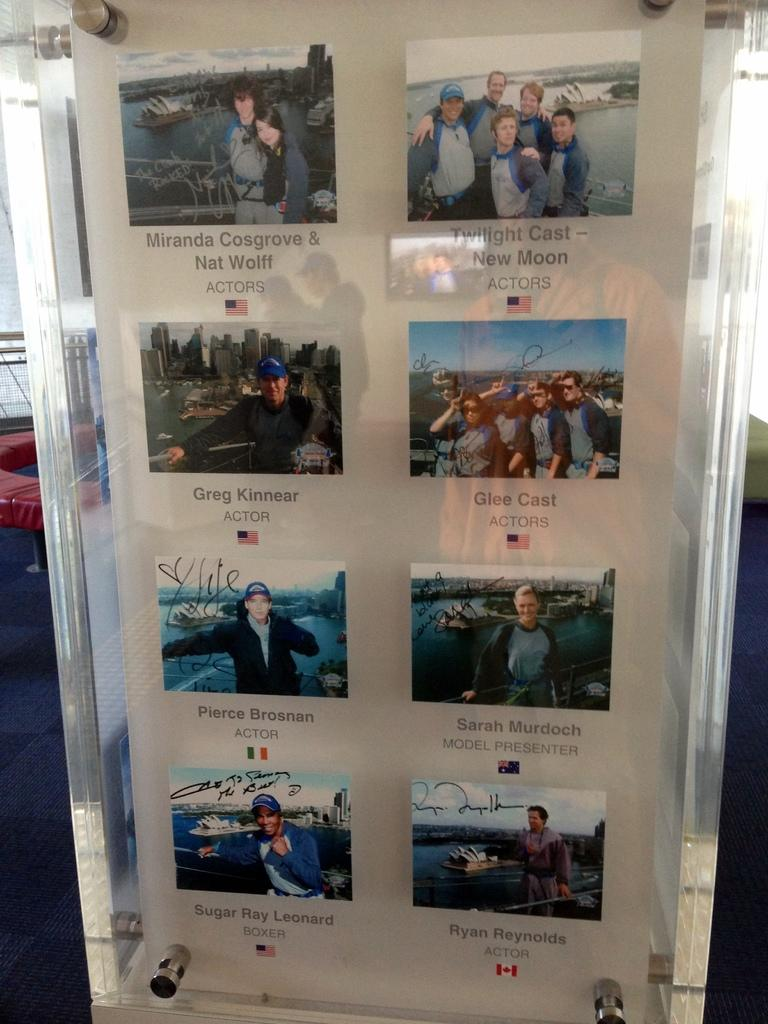<image>
Create a compact narrative representing the image presented. Sugar ray lenored  sits at the bottom right of a encasing with other people's pictures. 